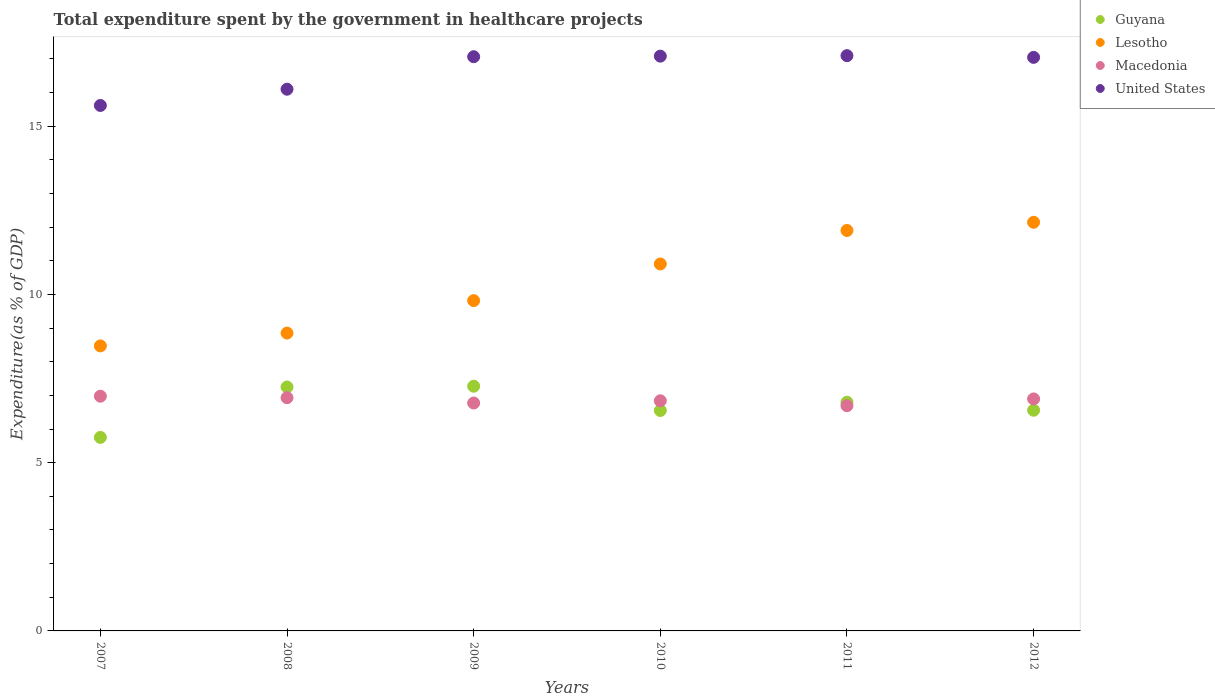Is the number of dotlines equal to the number of legend labels?
Ensure brevity in your answer.  Yes. What is the total expenditure spent by the government in healthcare projects in Macedonia in 2009?
Your response must be concise. 6.77. Across all years, what is the maximum total expenditure spent by the government in healthcare projects in Macedonia?
Your answer should be very brief. 6.98. Across all years, what is the minimum total expenditure spent by the government in healthcare projects in Guyana?
Ensure brevity in your answer.  5.75. What is the total total expenditure spent by the government in healthcare projects in Macedonia in the graph?
Keep it short and to the point. 41.11. What is the difference between the total expenditure spent by the government in healthcare projects in Guyana in 2010 and that in 2011?
Offer a very short reply. -0.25. What is the difference between the total expenditure spent by the government in healthcare projects in Guyana in 2012 and the total expenditure spent by the government in healthcare projects in Macedonia in 2009?
Offer a very short reply. -0.22. What is the average total expenditure spent by the government in healthcare projects in United States per year?
Offer a very short reply. 16.67. In the year 2012, what is the difference between the total expenditure spent by the government in healthcare projects in Guyana and total expenditure spent by the government in healthcare projects in Lesotho?
Provide a short and direct response. -5.59. What is the ratio of the total expenditure spent by the government in healthcare projects in United States in 2007 to that in 2012?
Your response must be concise. 0.92. What is the difference between the highest and the second highest total expenditure spent by the government in healthcare projects in United States?
Keep it short and to the point. 0.01. What is the difference between the highest and the lowest total expenditure spent by the government in healthcare projects in United States?
Ensure brevity in your answer.  1.48. Is it the case that in every year, the sum of the total expenditure spent by the government in healthcare projects in United States and total expenditure spent by the government in healthcare projects in Macedonia  is greater than the total expenditure spent by the government in healthcare projects in Guyana?
Provide a short and direct response. Yes. What is the difference between two consecutive major ticks on the Y-axis?
Provide a short and direct response. 5. Does the graph contain grids?
Make the answer very short. No. How are the legend labels stacked?
Offer a terse response. Vertical. What is the title of the graph?
Provide a short and direct response. Total expenditure spent by the government in healthcare projects. What is the label or title of the X-axis?
Your answer should be very brief. Years. What is the label or title of the Y-axis?
Your response must be concise. Expenditure(as % of GDP). What is the Expenditure(as % of GDP) of Guyana in 2007?
Provide a short and direct response. 5.75. What is the Expenditure(as % of GDP) of Lesotho in 2007?
Make the answer very short. 8.47. What is the Expenditure(as % of GDP) in Macedonia in 2007?
Provide a short and direct response. 6.98. What is the Expenditure(as % of GDP) of United States in 2007?
Provide a succinct answer. 15.62. What is the Expenditure(as % of GDP) of Guyana in 2008?
Give a very brief answer. 7.25. What is the Expenditure(as % of GDP) in Lesotho in 2008?
Your answer should be very brief. 8.85. What is the Expenditure(as % of GDP) in Macedonia in 2008?
Give a very brief answer. 6.93. What is the Expenditure(as % of GDP) in United States in 2008?
Provide a succinct answer. 16.1. What is the Expenditure(as % of GDP) in Guyana in 2009?
Provide a succinct answer. 7.27. What is the Expenditure(as % of GDP) of Lesotho in 2009?
Give a very brief answer. 9.82. What is the Expenditure(as % of GDP) in Macedonia in 2009?
Your answer should be compact. 6.77. What is the Expenditure(as % of GDP) of United States in 2009?
Keep it short and to the point. 17.07. What is the Expenditure(as % of GDP) of Guyana in 2010?
Provide a succinct answer. 6.55. What is the Expenditure(as % of GDP) in Lesotho in 2010?
Ensure brevity in your answer.  10.91. What is the Expenditure(as % of GDP) of Macedonia in 2010?
Give a very brief answer. 6.84. What is the Expenditure(as % of GDP) of United States in 2010?
Give a very brief answer. 17.08. What is the Expenditure(as % of GDP) of Guyana in 2011?
Ensure brevity in your answer.  6.8. What is the Expenditure(as % of GDP) in Lesotho in 2011?
Provide a short and direct response. 11.9. What is the Expenditure(as % of GDP) of Macedonia in 2011?
Keep it short and to the point. 6.69. What is the Expenditure(as % of GDP) in United States in 2011?
Your answer should be compact. 17.1. What is the Expenditure(as % of GDP) in Guyana in 2012?
Make the answer very short. 6.56. What is the Expenditure(as % of GDP) of Lesotho in 2012?
Give a very brief answer. 12.15. What is the Expenditure(as % of GDP) of Macedonia in 2012?
Provide a succinct answer. 6.9. What is the Expenditure(as % of GDP) in United States in 2012?
Provide a succinct answer. 17.05. Across all years, what is the maximum Expenditure(as % of GDP) in Guyana?
Offer a terse response. 7.27. Across all years, what is the maximum Expenditure(as % of GDP) of Lesotho?
Offer a terse response. 12.15. Across all years, what is the maximum Expenditure(as % of GDP) of Macedonia?
Your answer should be very brief. 6.98. Across all years, what is the maximum Expenditure(as % of GDP) in United States?
Your answer should be compact. 17.1. Across all years, what is the minimum Expenditure(as % of GDP) in Guyana?
Offer a terse response. 5.75. Across all years, what is the minimum Expenditure(as % of GDP) of Lesotho?
Your answer should be compact. 8.47. Across all years, what is the minimum Expenditure(as % of GDP) of Macedonia?
Keep it short and to the point. 6.69. Across all years, what is the minimum Expenditure(as % of GDP) of United States?
Keep it short and to the point. 15.62. What is the total Expenditure(as % of GDP) in Guyana in the graph?
Provide a succinct answer. 40.18. What is the total Expenditure(as % of GDP) of Lesotho in the graph?
Ensure brevity in your answer.  62.1. What is the total Expenditure(as % of GDP) in Macedonia in the graph?
Ensure brevity in your answer.  41.11. What is the total Expenditure(as % of GDP) in United States in the graph?
Provide a short and direct response. 100.01. What is the difference between the Expenditure(as % of GDP) in Guyana in 2007 and that in 2008?
Your answer should be very brief. -1.5. What is the difference between the Expenditure(as % of GDP) of Lesotho in 2007 and that in 2008?
Provide a short and direct response. -0.38. What is the difference between the Expenditure(as % of GDP) of Macedonia in 2007 and that in 2008?
Give a very brief answer. 0.04. What is the difference between the Expenditure(as % of GDP) in United States in 2007 and that in 2008?
Make the answer very short. -0.48. What is the difference between the Expenditure(as % of GDP) of Guyana in 2007 and that in 2009?
Your answer should be compact. -1.52. What is the difference between the Expenditure(as % of GDP) of Lesotho in 2007 and that in 2009?
Keep it short and to the point. -1.35. What is the difference between the Expenditure(as % of GDP) in Macedonia in 2007 and that in 2009?
Your response must be concise. 0.2. What is the difference between the Expenditure(as % of GDP) in United States in 2007 and that in 2009?
Provide a short and direct response. -1.45. What is the difference between the Expenditure(as % of GDP) in Guyana in 2007 and that in 2010?
Offer a very short reply. -0.8. What is the difference between the Expenditure(as % of GDP) in Lesotho in 2007 and that in 2010?
Ensure brevity in your answer.  -2.44. What is the difference between the Expenditure(as % of GDP) in Macedonia in 2007 and that in 2010?
Provide a short and direct response. 0.14. What is the difference between the Expenditure(as % of GDP) of United States in 2007 and that in 2010?
Your response must be concise. -1.47. What is the difference between the Expenditure(as % of GDP) of Guyana in 2007 and that in 2011?
Keep it short and to the point. -1.05. What is the difference between the Expenditure(as % of GDP) of Lesotho in 2007 and that in 2011?
Keep it short and to the point. -3.43. What is the difference between the Expenditure(as % of GDP) in Macedonia in 2007 and that in 2011?
Keep it short and to the point. 0.28. What is the difference between the Expenditure(as % of GDP) in United States in 2007 and that in 2011?
Give a very brief answer. -1.48. What is the difference between the Expenditure(as % of GDP) of Guyana in 2007 and that in 2012?
Give a very brief answer. -0.81. What is the difference between the Expenditure(as % of GDP) of Lesotho in 2007 and that in 2012?
Offer a very short reply. -3.67. What is the difference between the Expenditure(as % of GDP) in Macedonia in 2007 and that in 2012?
Provide a short and direct response. 0.08. What is the difference between the Expenditure(as % of GDP) in United States in 2007 and that in 2012?
Keep it short and to the point. -1.43. What is the difference between the Expenditure(as % of GDP) in Guyana in 2008 and that in 2009?
Your response must be concise. -0.02. What is the difference between the Expenditure(as % of GDP) in Lesotho in 2008 and that in 2009?
Your answer should be compact. -0.96. What is the difference between the Expenditure(as % of GDP) of Macedonia in 2008 and that in 2009?
Make the answer very short. 0.16. What is the difference between the Expenditure(as % of GDP) in United States in 2008 and that in 2009?
Give a very brief answer. -0.97. What is the difference between the Expenditure(as % of GDP) of Guyana in 2008 and that in 2010?
Your answer should be compact. 0.7. What is the difference between the Expenditure(as % of GDP) of Lesotho in 2008 and that in 2010?
Offer a very short reply. -2.05. What is the difference between the Expenditure(as % of GDP) in Macedonia in 2008 and that in 2010?
Offer a terse response. 0.09. What is the difference between the Expenditure(as % of GDP) of United States in 2008 and that in 2010?
Give a very brief answer. -0.98. What is the difference between the Expenditure(as % of GDP) of Guyana in 2008 and that in 2011?
Provide a short and direct response. 0.45. What is the difference between the Expenditure(as % of GDP) of Lesotho in 2008 and that in 2011?
Offer a terse response. -3.05. What is the difference between the Expenditure(as % of GDP) in Macedonia in 2008 and that in 2011?
Ensure brevity in your answer.  0.24. What is the difference between the Expenditure(as % of GDP) of United States in 2008 and that in 2011?
Make the answer very short. -1. What is the difference between the Expenditure(as % of GDP) of Guyana in 2008 and that in 2012?
Ensure brevity in your answer.  0.69. What is the difference between the Expenditure(as % of GDP) in Lesotho in 2008 and that in 2012?
Make the answer very short. -3.29. What is the difference between the Expenditure(as % of GDP) of Macedonia in 2008 and that in 2012?
Make the answer very short. 0.04. What is the difference between the Expenditure(as % of GDP) in United States in 2008 and that in 2012?
Your answer should be compact. -0.95. What is the difference between the Expenditure(as % of GDP) in Guyana in 2009 and that in 2010?
Provide a succinct answer. 0.72. What is the difference between the Expenditure(as % of GDP) of Lesotho in 2009 and that in 2010?
Your response must be concise. -1.09. What is the difference between the Expenditure(as % of GDP) of Macedonia in 2009 and that in 2010?
Make the answer very short. -0.07. What is the difference between the Expenditure(as % of GDP) in United States in 2009 and that in 2010?
Make the answer very short. -0.02. What is the difference between the Expenditure(as % of GDP) in Guyana in 2009 and that in 2011?
Make the answer very short. 0.48. What is the difference between the Expenditure(as % of GDP) of Lesotho in 2009 and that in 2011?
Offer a very short reply. -2.08. What is the difference between the Expenditure(as % of GDP) in United States in 2009 and that in 2011?
Keep it short and to the point. -0.03. What is the difference between the Expenditure(as % of GDP) of Guyana in 2009 and that in 2012?
Offer a terse response. 0.71. What is the difference between the Expenditure(as % of GDP) in Lesotho in 2009 and that in 2012?
Keep it short and to the point. -2.33. What is the difference between the Expenditure(as % of GDP) of Macedonia in 2009 and that in 2012?
Your answer should be very brief. -0.12. What is the difference between the Expenditure(as % of GDP) of United States in 2009 and that in 2012?
Provide a short and direct response. 0.02. What is the difference between the Expenditure(as % of GDP) in Guyana in 2010 and that in 2011?
Your answer should be very brief. -0.25. What is the difference between the Expenditure(as % of GDP) in Lesotho in 2010 and that in 2011?
Provide a short and direct response. -1. What is the difference between the Expenditure(as % of GDP) in Macedonia in 2010 and that in 2011?
Your response must be concise. 0.15. What is the difference between the Expenditure(as % of GDP) in United States in 2010 and that in 2011?
Make the answer very short. -0.01. What is the difference between the Expenditure(as % of GDP) of Guyana in 2010 and that in 2012?
Provide a short and direct response. -0.01. What is the difference between the Expenditure(as % of GDP) of Lesotho in 2010 and that in 2012?
Make the answer very short. -1.24. What is the difference between the Expenditure(as % of GDP) in Macedonia in 2010 and that in 2012?
Keep it short and to the point. -0.06. What is the difference between the Expenditure(as % of GDP) in United States in 2010 and that in 2012?
Offer a very short reply. 0.04. What is the difference between the Expenditure(as % of GDP) in Guyana in 2011 and that in 2012?
Provide a short and direct response. 0.24. What is the difference between the Expenditure(as % of GDP) of Lesotho in 2011 and that in 2012?
Your answer should be very brief. -0.24. What is the difference between the Expenditure(as % of GDP) in Macedonia in 2011 and that in 2012?
Your answer should be compact. -0.2. What is the difference between the Expenditure(as % of GDP) of United States in 2011 and that in 2012?
Ensure brevity in your answer.  0.05. What is the difference between the Expenditure(as % of GDP) of Guyana in 2007 and the Expenditure(as % of GDP) of Lesotho in 2008?
Ensure brevity in your answer.  -3.1. What is the difference between the Expenditure(as % of GDP) of Guyana in 2007 and the Expenditure(as % of GDP) of Macedonia in 2008?
Make the answer very short. -1.18. What is the difference between the Expenditure(as % of GDP) of Guyana in 2007 and the Expenditure(as % of GDP) of United States in 2008?
Ensure brevity in your answer.  -10.35. What is the difference between the Expenditure(as % of GDP) of Lesotho in 2007 and the Expenditure(as % of GDP) of Macedonia in 2008?
Your answer should be very brief. 1.54. What is the difference between the Expenditure(as % of GDP) in Lesotho in 2007 and the Expenditure(as % of GDP) in United States in 2008?
Offer a very short reply. -7.63. What is the difference between the Expenditure(as % of GDP) in Macedonia in 2007 and the Expenditure(as % of GDP) in United States in 2008?
Make the answer very short. -9.12. What is the difference between the Expenditure(as % of GDP) of Guyana in 2007 and the Expenditure(as % of GDP) of Lesotho in 2009?
Give a very brief answer. -4.07. What is the difference between the Expenditure(as % of GDP) in Guyana in 2007 and the Expenditure(as % of GDP) in Macedonia in 2009?
Give a very brief answer. -1.02. What is the difference between the Expenditure(as % of GDP) in Guyana in 2007 and the Expenditure(as % of GDP) in United States in 2009?
Offer a very short reply. -11.31. What is the difference between the Expenditure(as % of GDP) of Lesotho in 2007 and the Expenditure(as % of GDP) of Macedonia in 2009?
Give a very brief answer. 1.7. What is the difference between the Expenditure(as % of GDP) in Lesotho in 2007 and the Expenditure(as % of GDP) in United States in 2009?
Your response must be concise. -8.6. What is the difference between the Expenditure(as % of GDP) in Macedonia in 2007 and the Expenditure(as % of GDP) in United States in 2009?
Your answer should be very brief. -10.09. What is the difference between the Expenditure(as % of GDP) in Guyana in 2007 and the Expenditure(as % of GDP) in Lesotho in 2010?
Make the answer very short. -5.15. What is the difference between the Expenditure(as % of GDP) in Guyana in 2007 and the Expenditure(as % of GDP) in Macedonia in 2010?
Offer a very short reply. -1.09. What is the difference between the Expenditure(as % of GDP) of Guyana in 2007 and the Expenditure(as % of GDP) of United States in 2010?
Offer a terse response. -11.33. What is the difference between the Expenditure(as % of GDP) in Lesotho in 2007 and the Expenditure(as % of GDP) in Macedonia in 2010?
Ensure brevity in your answer.  1.63. What is the difference between the Expenditure(as % of GDP) in Lesotho in 2007 and the Expenditure(as % of GDP) in United States in 2010?
Your response must be concise. -8.61. What is the difference between the Expenditure(as % of GDP) of Macedonia in 2007 and the Expenditure(as % of GDP) of United States in 2010?
Keep it short and to the point. -10.11. What is the difference between the Expenditure(as % of GDP) in Guyana in 2007 and the Expenditure(as % of GDP) in Lesotho in 2011?
Make the answer very short. -6.15. What is the difference between the Expenditure(as % of GDP) in Guyana in 2007 and the Expenditure(as % of GDP) in Macedonia in 2011?
Your answer should be very brief. -0.94. What is the difference between the Expenditure(as % of GDP) of Guyana in 2007 and the Expenditure(as % of GDP) of United States in 2011?
Offer a terse response. -11.35. What is the difference between the Expenditure(as % of GDP) in Lesotho in 2007 and the Expenditure(as % of GDP) in Macedonia in 2011?
Provide a short and direct response. 1.78. What is the difference between the Expenditure(as % of GDP) in Lesotho in 2007 and the Expenditure(as % of GDP) in United States in 2011?
Provide a short and direct response. -8.63. What is the difference between the Expenditure(as % of GDP) of Macedonia in 2007 and the Expenditure(as % of GDP) of United States in 2011?
Make the answer very short. -10.12. What is the difference between the Expenditure(as % of GDP) in Guyana in 2007 and the Expenditure(as % of GDP) in Lesotho in 2012?
Your answer should be very brief. -6.39. What is the difference between the Expenditure(as % of GDP) of Guyana in 2007 and the Expenditure(as % of GDP) of Macedonia in 2012?
Keep it short and to the point. -1.14. What is the difference between the Expenditure(as % of GDP) of Guyana in 2007 and the Expenditure(as % of GDP) of United States in 2012?
Ensure brevity in your answer.  -11.3. What is the difference between the Expenditure(as % of GDP) of Lesotho in 2007 and the Expenditure(as % of GDP) of Macedonia in 2012?
Provide a short and direct response. 1.58. What is the difference between the Expenditure(as % of GDP) of Lesotho in 2007 and the Expenditure(as % of GDP) of United States in 2012?
Your response must be concise. -8.58. What is the difference between the Expenditure(as % of GDP) in Macedonia in 2007 and the Expenditure(as % of GDP) in United States in 2012?
Offer a terse response. -10.07. What is the difference between the Expenditure(as % of GDP) in Guyana in 2008 and the Expenditure(as % of GDP) in Lesotho in 2009?
Ensure brevity in your answer.  -2.57. What is the difference between the Expenditure(as % of GDP) in Guyana in 2008 and the Expenditure(as % of GDP) in Macedonia in 2009?
Offer a terse response. 0.48. What is the difference between the Expenditure(as % of GDP) in Guyana in 2008 and the Expenditure(as % of GDP) in United States in 2009?
Offer a very short reply. -9.82. What is the difference between the Expenditure(as % of GDP) of Lesotho in 2008 and the Expenditure(as % of GDP) of Macedonia in 2009?
Your answer should be compact. 2.08. What is the difference between the Expenditure(as % of GDP) of Lesotho in 2008 and the Expenditure(as % of GDP) of United States in 2009?
Provide a succinct answer. -8.21. What is the difference between the Expenditure(as % of GDP) in Macedonia in 2008 and the Expenditure(as % of GDP) in United States in 2009?
Offer a terse response. -10.13. What is the difference between the Expenditure(as % of GDP) of Guyana in 2008 and the Expenditure(as % of GDP) of Lesotho in 2010?
Provide a short and direct response. -3.66. What is the difference between the Expenditure(as % of GDP) in Guyana in 2008 and the Expenditure(as % of GDP) in Macedonia in 2010?
Ensure brevity in your answer.  0.41. What is the difference between the Expenditure(as % of GDP) of Guyana in 2008 and the Expenditure(as % of GDP) of United States in 2010?
Provide a short and direct response. -9.83. What is the difference between the Expenditure(as % of GDP) of Lesotho in 2008 and the Expenditure(as % of GDP) of Macedonia in 2010?
Your answer should be compact. 2.01. What is the difference between the Expenditure(as % of GDP) of Lesotho in 2008 and the Expenditure(as % of GDP) of United States in 2010?
Your response must be concise. -8.23. What is the difference between the Expenditure(as % of GDP) in Macedonia in 2008 and the Expenditure(as % of GDP) in United States in 2010?
Offer a very short reply. -10.15. What is the difference between the Expenditure(as % of GDP) in Guyana in 2008 and the Expenditure(as % of GDP) in Lesotho in 2011?
Provide a succinct answer. -4.65. What is the difference between the Expenditure(as % of GDP) of Guyana in 2008 and the Expenditure(as % of GDP) of Macedonia in 2011?
Keep it short and to the point. 0.56. What is the difference between the Expenditure(as % of GDP) in Guyana in 2008 and the Expenditure(as % of GDP) in United States in 2011?
Your response must be concise. -9.85. What is the difference between the Expenditure(as % of GDP) in Lesotho in 2008 and the Expenditure(as % of GDP) in Macedonia in 2011?
Keep it short and to the point. 2.16. What is the difference between the Expenditure(as % of GDP) of Lesotho in 2008 and the Expenditure(as % of GDP) of United States in 2011?
Offer a very short reply. -8.25. What is the difference between the Expenditure(as % of GDP) of Macedonia in 2008 and the Expenditure(as % of GDP) of United States in 2011?
Your answer should be very brief. -10.17. What is the difference between the Expenditure(as % of GDP) of Guyana in 2008 and the Expenditure(as % of GDP) of Lesotho in 2012?
Provide a short and direct response. -4.9. What is the difference between the Expenditure(as % of GDP) of Guyana in 2008 and the Expenditure(as % of GDP) of Macedonia in 2012?
Offer a very short reply. 0.35. What is the difference between the Expenditure(as % of GDP) of Guyana in 2008 and the Expenditure(as % of GDP) of United States in 2012?
Ensure brevity in your answer.  -9.8. What is the difference between the Expenditure(as % of GDP) of Lesotho in 2008 and the Expenditure(as % of GDP) of Macedonia in 2012?
Your response must be concise. 1.96. What is the difference between the Expenditure(as % of GDP) in Lesotho in 2008 and the Expenditure(as % of GDP) in United States in 2012?
Ensure brevity in your answer.  -8.2. What is the difference between the Expenditure(as % of GDP) of Macedonia in 2008 and the Expenditure(as % of GDP) of United States in 2012?
Offer a very short reply. -10.12. What is the difference between the Expenditure(as % of GDP) of Guyana in 2009 and the Expenditure(as % of GDP) of Lesotho in 2010?
Offer a terse response. -3.63. What is the difference between the Expenditure(as % of GDP) in Guyana in 2009 and the Expenditure(as % of GDP) in Macedonia in 2010?
Your response must be concise. 0.43. What is the difference between the Expenditure(as % of GDP) in Guyana in 2009 and the Expenditure(as % of GDP) in United States in 2010?
Offer a very short reply. -9.81. What is the difference between the Expenditure(as % of GDP) in Lesotho in 2009 and the Expenditure(as % of GDP) in Macedonia in 2010?
Give a very brief answer. 2.98. What is the difference between the Expenditure(as % of GDP) of Lesotho in 2009 and the Expenditure(as % of GDP) of United States in 2010?
Offer a terse response. -7.27. What is the difference between the Expenditure(as % of GDP) in Macedonia in 2009 and the Expenditure(as % of GDP) in United States in 2010?
Provide a short and direct response. -10.31. What is the difference between the Expenditure(as % of GDP) of Guyana in 2009 and the Expenditure(as % of GDP) of Lesotho in 2011?
Make the answer very short. -4.63. What is the difference between the Expenditure(as % of GDP) in Guyana in 2009 and the Expenditure(as % of GDP) in Macedonia in 2011?
Provide a short and direct response. 0.58. What is the difference between the Expenditure(as % of GDP) of Guyana in 2009 and the Expenditure(as % of GDP) of United States in 2011?
Your answer should be compact. -9.82. What is the difference between the Expenditure(as % of GDP) of Lesotho in 2009 and the Expenditure(as % of GDP) of Macedonia in 2011?
Keep it short and to the point. 3.12. What is the difference between the Expenditure(as % of GDP) of Lesotho in 2009 and the Expenditure(as % of GDP) of United States in 2011?
Keep it short and to the point. -7.28. What is the difference between the Expenditure(as % of GDP) in Macedonia in 2009 and the Expenditure(as % of GDP) in United States in 2011?
Ensure brevity in your answer.  -10.32. What is the difference between the Expenditure(as % of GDP) of Guyana in 2009 and the Expenditure(as % of GDP) of Lesotho in 2012?
Offer a terse response. -4.87. What is the difference between the Expenditure(as % of GDP) of Guyana in 2009 and the Expenditure(as % of GDP) of Macedonia in 2012?
Your answer should be compact. 0.38. What is the difference between the Expenditure(as % of GDP) of Guyana in 2009 and the Expenditure(as % of GDP) of United States in 2012?
Your answer should be very brief. -9.77. What is the difference between the Expenditure(as % of GDP) of Lesotho in 2009 and the Expenditure(as % of GDP) of Macedonia in 2012?
Your response must be concise. 2.92. What is the difference between the Expenditure(as % of GDP) in Lesotho in 2009 and the Expenditure(as % of GDP) in United States in 2012?
Give a very brief answer. -7.23. What is the difference between the Expenditure(as % of GDP) in Macedonia in 2009 and the Expenditure(as % of GDP) in United States in 2012?
Your response must be concise. -10.27. What is the difference between the Expenditure(as % of GDP) of Guyana in 2010 and the Expenditure(as % of GDP) of Lesotho in 2011?
Offer a very short reply. -5.35. What is the difference between the Expenditure(as % of GDP) in Guyana in 2010 and the Expenditure(as % of GDP) in Macedonia in 2011?
Make the answer very short. -0.14. What is the difference between the Expenditure(as % of GDP) of Guyana in 2010 and the Expenditure(as % of GDP) of United States in 2011?
Keep it short and to the point. -10.55. What is the difference between the Expenditure(as % of GDP) in Lesotho in 2010 and the Expenditure(as % of GDP) in Macedonia in 2011?
Your answer should be compact. 4.21. What is the difference between the Expenditure(as % of GDP) in Lesotho in 2010 and the Expenditure(as % of GDP) in United States in 2011?
Make the answer very short. -6.19. What is the difference between the Expenditure(as % of GDP) of Macedonia in 2010 and the Expenditure(as % of GDP) of United States in 2011?
Offer a terse response. -10.26. What is the difference between the Expenditure(as % of GDP) in Guyana in 2010 and the Expenditure(as % of GDP) in Lesotho in 2012?
Keep it short and to the point. -5.59. What is the difference between the Expenditure(as % of GDP) of Guyana in 2010 and the Expenditure(as % of GDP) of Macedonia in 2012?
Make the answer very short. -0.34. What is the difference between the Expenditure(as % of GDP) of Guyana in 2010 and the Expenditure(as % of GDP) of United States in 2012?
Make the answer very short. -10.5. What is the difference between the Expenditure(as % of GDP) of Lesotho in 2010 and the Expenditure(as % of GDP) of Macedonia in 2012?
Offer a very short reply. 4.01. What is the difference between the Expenditure(as % of GDP) in Lesotho in 2010 and the Expenditure(as % of GDP) in United States in 2012?
Offer a very short reply. -6.14. What is the difference between the Expenditure(as % of GDP) of Macedonia in 2010 and the Expenditure(as % of GDP) of United States in 2012?
Your answer should be very brief. -10.21. What is the difference between the Expenditure(as % of GDP) in Guyana in 2011 and the Expenditure(as % of GDP) in Lesotho in 2012?
Ensure brevity in your answer.  -5.35. What is the difference between the Expenditure(as % of GDP) of Guyana in 2011 and the Expenditure(as % of GDP) of Macedonia in 2012?
Your response must be concise. -0.1. What is the difference between the Expenditure(as % of GDP) in Guyana in 2011 and the Expenditure(as % of GDP) in United States in 2012?
Make the answer very short. -10.25. What is the difference between the Expenditure(as % of GDP) in Lesotho in 2011 and the Expenditure(as % of GDP) in Macedonia in 2012?
Provide a succinct answer. 5.01. What is the difference between the Expenditure(as % of GDP) in Lesotho in 2011 and the Expenditure(as % of GDP) in United States in 2012?
Give a very brief answer. -5.15. What is the difference between the Expenditure(as % of GDP) of Macedonia in 2011 and the Expenditure(as % of GDP) of United States in 2012?
Keep it short and to the point. -10.35. What is the average Expenditure(as % of GDP) in Guyana per year?
Offer a terse response. 6.7. What is the average Expenditure(as % of GDP) of Lesotho per year?
Give a very brief answer. 10.35. What is the average Expenditure(as % of GDP) in Macedonia per year?
Ensure brevity in your answer.  6.85. What is the average Expenditure(as % of GDP) in United States per year?
Your response must be concise. 16.67. In the year 2007, what is the difference between the Expenditure(as % of GDP) in Guyana and Expenditure(as % of GDP) in Lesotho?
Ensure brevity in your answer.  -2.72. In the year 2007, what is the difference between the Expenditure(as % of GDP) in Guyana and Expenditure(as % of GDP) in Macedonia?
Provide a short and direct response. -1.22. In the year 2007, what is the difference between the Expenditure(as % of GDP) in Guyana and Expenditure(as % of GDP) in United States?
Offer a very short reply. -9.87. In the year 2007, what is the difference between the Expenditure(as % of GDP) in Lesotho and Expenditure(as % of GDP) in Macedonia?
Ensure brevity in your answer.  1.5. In the year 2007, what is the difference between the Expenditure(as % of GDP) of Lesotho and Expenditure(as % of GDP) of United States?
Keep it short and to the point. -7.15. In the year 2007, what is the difference between the Expenditure(as % of GDP) in Macedonia and Expenditure(as % of GDP) in United States?
Offer a very short reply. -8.64. In the year 2008, what is the difference between the Expenditure(as % of GDP) of Guyana and Expenditure(as % of GDP) of Lesotho?
Provide a succinct answer. -1.6. In the year 2008, what is the difference between the Expenditure(as % of GDP) of Guyana and Expenditure(as % of GDP) of Macedonia?
Your response must be concise. 0.32. In the year 2008, what is the difference between the Expenditure(as % of GDP) in Guyana and Expenditure(as % of GDP) in United States?
Your answer should be very brief. -8.85. In the year 2008, what is the difference between the Expenditure(as % of GDP) of Lesotho and Expenditure(as % of GDP) of Macedonia?
Keep it short and to the point. 1.92. In the year 2008, what is the difference between the Expenditure(as % of GDP) in Lesotho and Expenditure(as % of GDP) in United States?
Make the answer very short. -7.25. In the year 2008, what is the difference between the Expenditure(as % of GDP) of Macedonia and Expenditure(as % of GDP) of United States?
Give a very brief answer. -9.17. In the year 2009, what is the difference between the Expenditure(as % of GDP) in Guyana and Expenditure(as % of GDP) in Lesotho?
Your response must be concise. -2.54. In the year 2009, what is the difference between the Expenditure(as % of GDP) in Guyana and Expenditure(as % of GDP) in Macedonia?
Keep it short and to the point. 0.5. In the year 2009, what is the difference between the Expenditure(as % of GDP) in Guyana and Expenditure(as % of GDP) in United States?
Give a very brief answer. -9.79. In the year 2009, what is the difference between the Expenditure(as % of GDP) in Lesotho and Expenditure(as % of GDP) in Macedonia?
Keep it short and to the point. 3.04. In the year 2009, what is the difference between the Expenditure(as % of GDP) of Lesotho and Expenditure(as % of GDP) of United States?
Provide a short and direct response. -7.25. In the year 2009, what is the difference between the Expenditure(as % of GDP) in Macedonia and Expenditure(as % of GDP) in United States?
Offer a terse response. -10.29. In the year 2010, what is the difference between the Expenditure(as % of GDP) of Guyana and Expenditure(as % of GDP) of Lesotho?
Keep it short and to the point. -4.35. In the year 2010, what is the difference between the Expenditure(as % of GDP) in Guyana and Expenditure(as % of GDP) in Macedonia?
Keep it short and to the point. -0.29. In the year 2010, what is the difference between the Expenditure(as % of GDP) of Guyana and Expenditure(as % of GDP) of United States?
Offer a terse response. -10.53. In the year 2010, what is the difference between the Expenditure(as % of GDP) in Lesotho and Expenditure(as % of GDP) in Macedonia?
Give a very brief answer. 4.07. In the year 2010, what is the difference between the Expenditure(as % of GDP) in Lesotho and Expenditure(as % of GDP) in United States?
Make the answer very short. -6.18. In the year 2010, what is the difference between the Expenditure(as % of GDP) of Macedonia and Expenditure(as % of GDP) of United States?
Offer a very short reply. -10.24. In the year 2011, what is the difference between the Expenditure(as % of GDP) of Guyana and Expenditure(as % of GDP) of Lesotho?
Offer a terse response. -5.11. In the year 2011, what is the difference between the Expenditure(as % of GDP) of Guyana and Expenditure(as % of GDP) of Macedonia?
Offer a terse response. 0.1. In the year 2011, what is the difference between the Expenditure(as % of GDP) of Guyana and Expenditure(as % of GDP) of United States?
Offer a terse response. -10.3. In the year 2011, what is the difference between the Expenditure(as % of GDP) in Lesotho and Expenditure(as % of GDP) in Macedonia?
Ensure brevity in your answer.  5.21. In the year 2011, what is the difference between the Expenditure(as % of GDP) of Lesotho and Expenditure(as % of GDP) of United States?
Offer a very short reply. -5.2. In the year 2011, what is the difference between the Expenditure(as % of GDP) in Macedonia and Expenditure(as % of GDP) in United States?
Offer a very short reply. -10.4. In the year 2012, what is the difference between the Expenditure(as % of GDP) in Guyana and Expenditure(as % of GDP) in Lesotho?
Offer a very short reply. -5.59. In the year 2012, what is the difference between the Expenditure(as % of GDP) of Guyana and Expenditure(as % of GDP) of Macedonia?
Make the answer very short. -0.34. In the year 2012, what is the difference between the Expenditure(as % of GDP) in Guyana and Expenditure(as % of GDP) in United States?
Your answer should be compact. -10.49. In the year 2012, what is the difference between the Expenditure(as % of GDP) of Lesotho and Expenditure(as % of GDP) of Macedonia?
Give a very brief answer. 5.25. In the year 2012, what is the difference between the Expenditure(as % of GDP) in Lesotho and Expenditure(as % of GDP) in United States?
Offer a terse response. -4.9. In the year 2012, what is the difference between the Expenditure(as % of GDP) in Macedonia and Expenditure(as % of GDP) in United States?
Your response must be concise. -10.15. What is the ratio of the Expenditure(as % of GDP) in Guyana in 2007 to that in 2008?
Your answer should be very brief. 0.79. What is the ratio of the Expenditure(as % of GDP) in Lesotho in 2007 to that in 2008?
Offer a very short reply. 0.96. What is the ratio of the Expenditure(as % of GDP) of Macedonia in 2007 to that in 2008?
Offer a terse response. 1.01. What is the ratio of the Expenditure(as % of GDP) of United States in 2007 to that in 2008?
Offer a very short reply. 0.97. What is the ratio of the Expenditure(as % of GDP) in Guyana in 2007 to that in 2009?
Offer a terse response. 0.79. What is the ratio of the Expenditure(as % of GDP) of Lesotho in 2007 to that in 2009?
Offer a terse response. 0.86. What is the ratio of the Expenditure(as % of GDP) of Macedonia in 2007 to that in 2009?
Provide a succinct answer. 1.03. What is the ratio of the Expenditure(as % of GDP) in United States in 2007 to that in 2009?
Offer a very short reply. 0.92. What is the ratio of the Expenditure(as % of GDP) of Guyana in 2007 to that in 2010?
Give a very brief answer. 0.88. What is the ratio of the Expenditure(as % of GDP) in Lesotho in 2007 to that in 2010?
Ensure brevity in your answer.  0.78. What is the ratio of the Expenditure(as % of GDP) in Macedonia in 2007 to that in 2010?
Provide a short and direct response. 1.02. What is the ratio of the Expenditure(as % of GDP) of United States in 2007 to that in 2010?
Offer a terse response. 0.91. What is the ratio of the Expenditure(as % of GDP) of Guyana in 2007 to that in 2011?
Offer a very short reply. 0.85. What is the ratio of the Expenditure(as % of GDP) of Lesotho in 2007 to that in 2011?
Your response must be concise. 0.71. What is the ratio of the Expenditure(as % of GDP) in Macedonia in 2007 to that in 2011?
Your answer should be very brief. 1.04. What is the ratio of the Expenditure(as % of GDP) in United States in 2007 to that in 2011?
Give a very brief answer. 0.91. What is the ratio of the Expenditure(as % of GDP) of Guyana in 2007 to that in 2012?
Your response must be concise. 0.88. What is the ratio of the Expenditure(as % of GDP) of Lesotho in 2007 to that in 2012?
Your answer should be very brief. 0.7. What is the ratio of the Expenditure(as % of GDP) in Macedonia in 2007 to that in 2012?
Offer a very short reply. 1.01. What is the ratio of the Expenditure(as % of GDP) in United States in 2007 to that in 2012?
Keep it short and to the point. 0.92. What is the ratio of the Expenditure(as % of GDP) in Lesotho in 2008 to that in 2009?
Keep it short and to the point. 0.9. What is the ratio of the Expenditure(as % of GDP) in Macedonia in 2008 to that in 2009?
Ensure brevity in your answer.  1.02. What is the ratio of the Expenditure(as % of GDP) in United States in 2008 to that in 2009?
Give a very brief answer. 0.94. What is the ratio of the Expenditure(as % of GDP) in Guyana in 2008 to that in 2010?
Offer a very short reply. 1.11. What is the ratio of the Expenditure(as % of GDP) of Lesotho in 2008 to that in 2010?
Your answer should be very brief. 0.81. What is the ratio of the Expenditure(as % of GDP) in Macedonia in 2008 to that in 2010?
Offer a terse response. 1.01. What is the ratio of the Expenditure(as % of GDP) of United States in 2008 to that in 2010?
Give a very brief answer. 0.94. What is the ratio of the Expenditure(as % of GDP) in Guyana in 2008 to that in 2011?
Your response must be concise. 1.07. What is the ratio of the Expenditure(as % of GDP) of Lesotho in 2008 to that in 2011?
Your response must be concise. 0.74. What is the ratio of the Expenditure(as % of GDP) in Macedonia in 2008 to that in 2011?
Your answer should be very brief. 1.04. What is the ratio of the Expenditure(as % of GDP) of United States in 2008 to that in 2011?
Ensure brevity in your answer.  0.94. What is the ratio of the Expenditure(as % of GDP) of Guyana in 2008 to that in 2012?
Provide a short and direct response. 1.11. What is the ratio of the Expenditure(as % of GDP) in Lesotho in 2008 to that in 2012?
Make the answer very short. 0.73. What is the ratio of the Expenditure(as % of GDP) of Macedonia in 2008 to that in 2012?
Provide a short and direct response. 1.01. What is the ratio of the Expenditure(as % of GDP) of United States in 2008 to that in 2012?
Your answer should be compact. 0.94. What is the ratio of the Expenditure(as % of GDP) in Guyana in 2009 to that in 2010?
Offer a terse response. 1.11. What is the ratio of the Expenditure(as % of GDP) in Lesotho in 2009 to that in 2010?
Your answer should be compact. 0.9. What is the ratio of the Expenditure(as % of GDP) of Guyana in 2009 to that in 2011?
Give a very brief answer. 1.07. What is the ratio of the Expenditure(as % of GDP) in Lesotho in 2009 to that in 2011?
Provide a succinct answer. 0.82. What is the ratio of the Expenditure(as % of GDP) in Macedonia in 2009 to that in 2011?
Your answer should be very brief. 1.01. What is the ratio of the Expenditure(as % of GDP) in United States in 2009 to that in 2011?
Give a very brief answer. 1. What is the ratio of the Expenditure(as % of GDP) in Guyana in 2009 to that in 2012?
Offer a terse response. 1.11. What is the ratio of the Expenditure(as % of GDP) in Lesotho in 2009 to that in 2012?
Offer a very short reply. 0.81. What is the ratio of the Expenditure(as % of GDP) in Macedonia in 2009 to that in 2012?
Offer a terse response. 0.98. What is the ratio of the Expenditure(as % of GDP) of Guyana in 2010 to that in 2011?
Offer a terse response. 0.96. What is the ratio of the Expenditure(as % of GDP) in Lesotho in 2010 to that in 2011?
Provide a succinct answer. 0.92. What is the ratio of the Expenditure(as % of GDP) of Macedonia in 2010 to that in 2011?
Make the answer very short. 1.02. What is the ratio of the Expenditure(as % of GDP) of Guyana in 2010 to that in 2012?
Make the answer very short. 1. What is the ratio of the Expenditure(as % of GDP) in Lesotho in 2010 to that in 2012?
Your answer should be compact. 0.9. What is the ratio of the Expenditure(as % of GDP) of Macedonia in 2010 to that in 2012?
Your answer should be very brief. 0.99. What is the ratio of the Expenditure(as % of GDP) in Guyana in 2011 to that in 2012?
Keep it short and to the point. 1.04. What is the ratio of the Expenditure(as % of GDP) in Lesotho in 2011 to that in 2012?
Provide a succinct answer. 0.98. What is the ratio of the Expenditure(as % of GDP) in Macedonia in 2011 to that in 2012?
Ensure brevity in your answer.  0.97. What is the difference between the highest and the second highest Expenditure(as % of GDP) of Guyana?
Keep it short and to the point. 0.02. What is the difference between the highest and the second highest Expenditure(as % of GDP) of Lesotho?
Ensure brevity in your answer.  0.24. What is the difference between the highest and the second highest Expenditure(as % of GDP) of Macedonia?
Your answer should be very brief. 0.04. What is the difference between the highest and the second highest Expenditure(as % of GDP) of United States?
Ensure brevity in your answer.  0.01. What is the difference between the highest and the lowest Expenditure(as % of GDP) in Guyana?
Your answer should be very brief. 1.52. What is the difference between the highest and the lowest Expenditure(as % of GDP) in Lesotho?
Provide a succinct answer. 3.67. What is the difference between the highest and the lowest Expenditure(as % of GDP) of Macedonia?
Offer a terse response. 0.28. What is the difference between the highest and the lowest Expenditure(as % of GDP) of United States?
Provide a short and direct response. 1.48. 